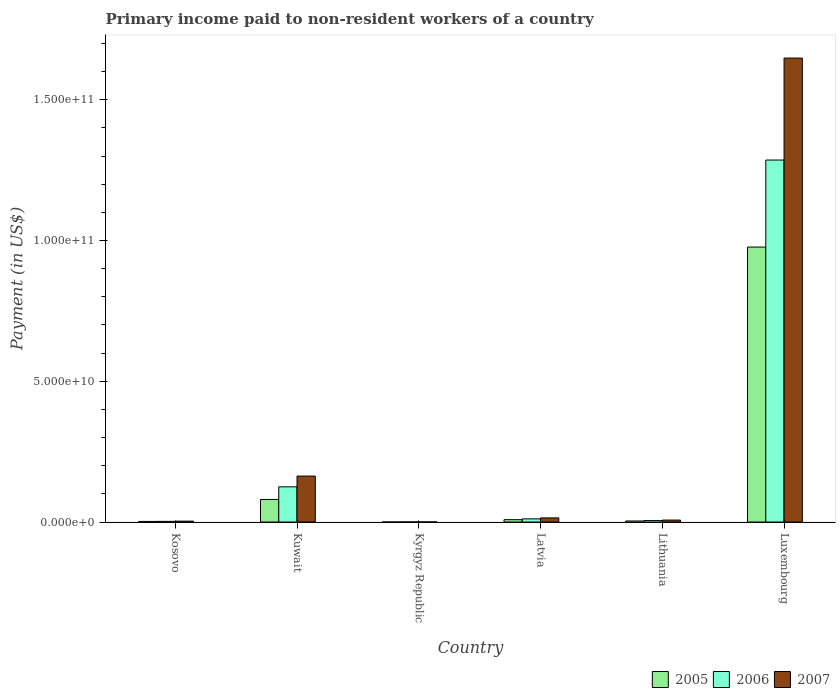How many different coloured bars are there?
Make the answer very short. 3. How many groups of bars are there?
Provide a succinct answer. 6. What is the label of the 6th group of bars from the left?
Provide a succinct answer. Luxembourg. In how many cases, is the number of bars for a given country not equal to the number of legend labels?
Your answer should be compact. 0. What is the amount paid to workers in 2007 in Latvia?
Give a very brief answer. 1.47e+09. Across all countries, what is the maximum amount paid to workers in 2006?
Your response must be concise. 1.29e+11. Across all countries, what is the minimum amount paid to workers in 2007?
Offer a very short reply. 4.26e+07. In which country was the amount paid to workers in 2007 maximum?
Keep it short and to the point. Luxembourg. In which country was the amount paid to workers in 2006 minimum?
Provide a succinct answer. Kyrgyz Republic. What is the total amount paid to workers in 2007 in the graph?
Your answer should be compact. 1.84e+11. What is the difference between the amount paid to workers in 2006 in Kyrgyz Republic and that in Luxembourg?
Offer a terse response. -1.29e+11. What is the difference between the amount paid to workers in 2006 in Luxembourg and the amount paid to workers in 2005 in Kosovo?
Your answer should be very brief. 1.28e+11. What is the average amount paid to workers in 2005 per country?
Your answer should be compact. 1.79e+1. What is the difference between the amount paid to workers of/in 2007 and amount paid to workers of/in 2006 in Latvia?
Ensure brevity in your answer.  3.44e+08. In how many countries, is the amount paid to workers in 2007 greater than 20000000000 US$?
Keep it short and to the point. 1. What is the ratio of the amount paid to workers in 2006 in Lithuania to that in Luxembourg?
Make the answer very short. 0. Is the difference between the amount paid to workers in 2007 in Lithuania and Luxembourg greater than the difference between the amount paid to workers in 2006 in Lithuania and Luxembourg?
Ensure brevity in your answer.  No. What is the difference between the highest and the second highest amount paid to workers in 2006?
Your answer should be compact. 1.27e+11. What is the difference between the highest and the lowest amount paid to workers in 2006?
Make the answer very short. 1.29e+11. What does the 3rd bar from the right in Kyrgyz Republic represents?
Provide a short and direct response. 2005. Is it the case that in every country, the sum of the amount paid to workers in 2006 and amount paid to workers in 2005 is greater than the amount paid to workers in 2007?
Make the answer very short. Yes. How many bars are there?
Offer a very short reply. 18. Are all the bars in the graph horizontal?
Ensure brevity in your answer.  No. How many countries are there in the graph?
Give a very brief answer. 6. Where does the legend appear in the graph?
Give a very brief answer. Bottom right. How many legend labels are there?
Your answer should be very brief. 3. How are the legend labels stacked?
Keep it short and to the point. Horizontal. What is the title of the graph?
Your answer should be very brief. Primary income paid to non-resident workers of a country. Does "1965" appear as one of the legend labels in the graph?
Give a very brief answer. No. What is the label or title of the Y-axis?
Offer a terse response. Payment (in US$). What is the Payment (in US$) in 2005 in Kosovo?
Your answer should be compact. 2.12e+08. What is the Payment (in US$) in 2006 in Kosovo?
Provide a short and direct response. 2.36e+08. What is the Payment (in US$) of 2007 in Kosovo?
Your answer should be compact. 3.23e+08. What is the Payment (in US$) in 2005 in Kuwait?
Offer a terse response. 8.02e+09. What is the Payment (in US$) in 2006 in Kuwait?
Give a very brief answer. 1.25e+1. What is the Payment (in US$) of 2007 in Kuwait?
Provide a succinct answer. 1.63e+1. What is the Payment (in US$) in 2005 in Kyrgyz Republic?
Offer a very short reply. 1.65e+07. What is the Payment (in US$) of 2006 in Kyrgyz Republic?
Provide a succinct answer. 4.16e+07. What is the Payment (in US$) of 2007 in Kyrgyz Republic?
Give a very brief answer. 4.26e+07. What is the Payment (in US$) in 2005 in Latvia?
Offer a terse response. 8.40e+08. What is the Payment (in US$) of 2006 in Latvia?
Your answer should be very brief. 1.13e+09. What is the Payment (in US$) of 2007 in Latvia?
Your answer should be very brief. 1.47e+09. What is the Payment (in US$) of 2005 in Lithuania?
Offer a terse response. 3.75e+08. What is the Payment (in US$) of 2006 in Lithuania?
Provide a short and direct response. 5.17e+08. What is the Payment (in US$) in 2007 in Lithuania?
Your answer should be compact. 6.99e+08. What is the Payment (in US$) of 2005 in Luxembourg?
Keep it short and to the point. 9.77e+1. What is the Payment (in US$) in 2006 in Luxembourg?
Offer a very short reply. 1.29e+11. What is the Payment (in US$) in 2007 in Luxembourg?
Keep it short and to the point. 1.65e+11. Across all countries, what is the maximum Payment (in US$) in 2005?
Your answer should be very brief. 9.77e+1. Across all countries, what is the maximum Payment (in US$) of 2006?
Offer a terse response. 1.29e+11. Across all countries, what is the maximum Payment (in US$) of 2007?
Provide a short and direct response. 1.65e+11. Across all countries, what is the minimum Payment (in US$) in 2005?
Give a very brief answer. 1.65e+07. Across all countries, what is the minimum Payment (in US$) in 2006?
Your answer should be compact. 4.16e+07. Across all countries, what is the minimum Payment (in US$) in 2007?
Keep it short and to the point. 4.26e+07. What is the total Payment (in US$) in 2005 in the graph?
Make the answer very short. 1.07e+11. What is the total Payment (in US$) in 2006 in the graph?
Offer a very short reply. 1.43e+11. What is the total Payment (in US$) in 2007 in the graph?
Offer a very short reply. 1.84e+11. What is the difference between the Payment (in US$) of 2005 in Kosovo and that in Kuwait?
Keep it short and to the point. -7.81e+09. What is the difference between the Payment (in US$) of 2006 in Kosovo and that in Kuwait?
Offer a terse response. -1.23e+1. What is the difference between the Payment (in US$) in 2007 in Kosovo and that in Kuwait?
Your answer should be very brief. -1.60e+1. What is the difference between the Payment (in US$) in 2005 in Kosovo and that in Kyrgyz Republic?
Make the answer very short. 1.95e+08. What is the difference between the Payment (in US$) of 2006 in Kosovo and that in Kyrgyz Republic?
Keep it short and to the point. 1.94e+08. What is the difference between the Payment (in US$) of 2007 in Kosovo and that in Kyrgyz Republic?
Offer a very short reply. 2.80e+08. What is the difference between the Payment (in US$) of 2005 in Kosovo and that in Latvia?
Provide a short and direct response. -6.28e+08. What is the difference between the Payment (in US$) in 2006 in Kosovo and that in Latvia?
Offer a very short reply. -8.91e+08. What is the difference between the Payment (in US$) in 2007 in Kosovo and that in Latvia?
Give a very brief answer. -1.15e+09. What is the difference between the Payment (in US$) in 2005 in Kosovo and that in Lithuania?
Your answer should be very brief. -1.63e+08. What is the difference between the Payment (in US$) of 2006 in Kosovo and that in Lithuania?
Provide a short and direct response. -2.82e+08. What is the difference between the Payment (in US$) in 2007 in Kosovo and that in Lithuania?
Make the answer very short. -3.76e+08. What is the difference between the Payment (in US$) in 2005 in Kosovo and that in Luxembourg?
Give a very brief answer. -9.74e+1. What is the difference between the Payment (in US$) of 2006 in Kosovo and that in Luxembourg?
Keep it short and to the point. -1.28e+11. What is the difference between the Payment (in US$) of 2007 in Kosovo and that in Luxembourg?
Make the answer very short. -1.64e+11. What is the difference between the Payment (in US$) in 2005 in Kuwait and that in Kyrgyz Republic?
Keep it short and to the point. 8.01e+09. What is the difference between the Payment (in US$) in 2006 in Kuwait and that in Kyrgyz Republic?
Your answer should be very brief. 1.25e+1. What is the difference between the Payment (in US$) in 2007 in Kuwait and that in Kyrgyz Republic?
Your answer should be compact. 1.63e+1. What is the difference between the Payment (in US$) in 2005 in Kuwait and that in Latvia?
Ensure brevity in your answer.  7.18e+09. What is the difference between the Payment (in US$) in 2006 in Kuwait and that in Latvia?
Keep it short and to the point. 1.14e+1. What is the difference between the Payment (in US$) in 2007 in Kuwait and that in Latvia?
Ensure brevity in your answer.  1.49e+1. What is the difference between the Payment (in US$) of 2005 in Kuwait and that in Lithuania?
Make the answer very short. 7.65e+09. What is the difference between the Payment (in US$) in 2006 in Kuwait and that in Lithuania?
Make the answer very short. 1.20e+1. What is the difference between the Payment (in US$) of 2007 in Kuwait and that in Lithuania?
Keep it short and to the point. 1.56e+1. What is the difference between the Payment (in US$) in 2005 in Kuwait and that in Luxembourg?
Provide a short and direct response. -8.96e+1. What is the difference between the Payment (in US$) in 2006 in Kuwait and that in Luxembourg?
Offer a very short reply. -1.16e+11. What is the difference between the Payment (in US$) in 2007 in Kuwait and that in Luxembourg?
Make the answer very short. -1.48e+11. What is the difference between the Payment (in US$) of 2005 in Kyrgyz Republic and that in Latvia?
Provide a short and direct response. -8.23e+08. What is the difference between the Payment (in US$) of 2006 in Kyrgyz Republic and that in Latvia?
Offer a terse response. -1.09e+09. What is the difference between the Payment (in US$) of 2007 in Kyrgyz Republic and that in Latvia?
Make the answer very short. -1.43e+09. What is the difference between the Payment (in US$) in 2005 in Kyrgyz Republic and that in Lithuania?
Make the answer very short. -3.58e+08. What is the difference between the Payment (in US$) in 2006 in Kyrgyz Republic and that in Lithuania?
Provide a succinct answer. -4.76e+08. What is the difference between the Payment (in US$) of 2007 in Kyrgyz Republic and that in Lithuania?
Offer a terse response. -6.56e+08. What is the difference between the Payment (in US$) of 2005 in Kyrgyz Republic and that in Luxembourg?
Ensure brevity in your answer.  -9.76e+1. What is the difference between the Payment (in US$) of 2006 in Kyrgyz Republic and that in Luxembourg?
Provide a short and direct response. -1.29e+11. What is the difference between the Payment (in US$) in 2007 in Kyrgyz Republic and that in Luxembourg?
Provide a succinct answer. -1.65e+11. What is the difference between the Payment (in US$) of 2005 in Latvia and that in Lithuania?
Offer a very short reply. 4.65e+08. What is the difference between the Payment (in US$) in 2006 in Latvia and that in Lithuania?
Keep it short and to the point. 6.10e+08. What is the difference between the Payment (in US$) in 2007 in Latvia and that in Lithuania?
Offer a very short reply. 7.72e+08. What is the difference between the Payment (in US$) in 2005 in Latvia and that in Luxembourg?
Make the answer very short. -9.68e+1. What is the difference between the Payment (in US$) of 2006 in Latvia and that in Luxembourg?
Your answer should be very brief. -1.27e+11. What is the difference between the Payment (in US$) of 2007 in Latvia and that in Luxembourg?
Your answer should be compact. -1.63e+11. What is the difference between the Payment (in US$) in 2005 in Lithuania and that in Luxembourg?
Your answer should be very brief. -9.73e+1. What is the difference between the Payment (in US$) of 2006 in Lithuania and that in Luxembourg?
Keep it short and to the point. -1.28e+11. What is the difference between the Payment (in US$) of 2007 in Lithuania and that in Luxembourg?
Give a very brief answer. -1.64e+11. What is the difference between the Payment (in US$) in 2005 in Kosovo and the Payment (in US$) in 2006 in Kuwait?
Your response must be concise. -1.23e+1. What is the difference between the Payment (in US$) of 2005 in Kosovo and the Payment (in US$) of 2007 in Kuwait?
Your answer should be very brief. -1.61e+1. What is the difference between the Payment (in US$) of 2006 in Kosovo and the Payment (in US$) of 2007 in Kuwait?
Provide a short and direct response. -1.61e+1. What is the difference between the Payment (in US$) in 2005 in Kosovo and the Payment (in US$) in 2006 in Kyrgyz Republic?
Offer a very short reply. 1.70e+08. What is the difference between the Payment (in US$) of 2005 in Kosovo and the Payment (in US$) of 2007 in Kyrgyz Republic?
Offer a very short reply. 1.69e+08. What is the difference between the Payment (in US$) in 2006 in Kosovo and the Payment (in US$) in 2007 in Kyrgyz Republic?
Provide a short and direct response. 1.93e+08. What is the difference between the Payment (in US$) in 2005 in Kosovo and the Payment (in US$) in 2006 in Latvia?
Offer a terse response. -9.15e+08. What is the difference between the Payment (in US$) in 2005 in Kosovo and the Payment (in US$) in 2007 in Latvia?
Your response must be concise. -1.26e+09. What is the difference between the Payment (in US$) of 2006 in Kosovo and the Payment (in US$) of 2007 in Latvia?
Your answer should be compact. -1.24e+09. What is the difference between the Payment (in US$) in 2005 in Kosovo and the Payment (in US$) in 2006 in Lithuania?
Provide a succinct answer. -3.05e+08. What is the difference between the Payment (in US$) of 2005 in Kosovo and the Payment (in US$) of 2007 in Lithuania?
Ensure brevity in your answer.  -4.87e+08. What is the difference between the Payment (in US$) in 2006 in Kosovo and the Payment (in US$) in 2007 in Lithuania?
Provide a short and direct response. -4.63e+08. What is the difference between the Payment (in US$) of 2005 in Kosovo and the Payment (in US$) of 2006 in Luxembourg?
Offer a very short reply. -1.28e+11. What is the difference between the Payment (in US$) of 2005 in Kosovo and the Payment (in US$) of 2007 in Luxembourg?
Offer a terse response. -1.65e+11. What is the difference between the Payment (in US$) in 2006 in Kosovo and the Payment (in US$) in 2007 in Luxembourg?
Offer a very short reply. -1.65e+11. What is the difference between the Payment (in US$) in 2005 in Kuwait and the Payment (in US$) in 2006 in Kyrgyz Republic?
Keep it short and to the point. 7.98e+09. What is the difference between the Payment (in US$) in 2005 in Kuwait and the Payment (in US$) in 2007 in Kyrgyz Republic?
Your answer should be compact. 7.98e+09. What is the difference between the Payment (in US$) in 2006 in Kuwait and the Payment (in US$) in 2007 in Kyrgyz Republic?
Ensure brevity in your answer.  1.25e+1. What is the difference between the Payment (in US$) in 2005 in Kuwait and the Payment (in US$) in 2006 in Latvia?
Your answer should be very brief. 6.90e+09. What is the difference between the Payment (in US$) of 2005 in Kuwait and the Payment (in US$) of 2007 in Latvia?
Your response must be concise. 6.55e+09. What is the difference between the Payment (in US$) in 2006 in Kuwait and the Payment (in US$) in 2007 in Latvia?
Your answer should be compact. 1.10e+1. What is the difference between the Payment (in US$) of 2005 in Kuwait and the Payment (in US$) of 2006 in Lithuania?
Provide a short and direct response. 7.51e+09. What is the difference between the Payment (in US$) in 2005 in Kuwait and the Payment (in US$) in 2007 in Lithuania?
Keep it short and to the point. 7.32e+09. What is the difference between the Payment (in US$) in 2006 in Kuwait and the Payment (in US$) in 2007 in Lithuania?
Your answer should be compact. 1.18e+1. What is the difference between the Payment (in US$) of 2005 in Kuwait and the Payment (in US$) of 2006 in Luxembourg?
Offer a terse response. -1.21e+11. What is the difference between the Payment (in US$) in 2005 in Kuwait and the Payment (in US$) in 2007 in Luxembourg?
Your answer should be very brief. -1.57e+11. What is the difference between the Payment (in US$) of 2006 in Kuwait and the Payment (in US$) of 2007 in Luxembourg?
Your answer should be very brief. -1.52e+11. What is the difference between the Payment (in US$) in 2005 in Kyrgyz Republic and the Payment (in US$) in 2006 in Latvia?
Make the answer very short. -1.11e+09. What is the difference between the Payment (in US$) in 2005 in Kyrgyz Republic and the Payment (in US$) in 2007 in Latvia?
Your response must be concise. -1.45e+09. What is the difference between the Payment (in US$) of 2006 in Kyrgyz Republic and the Payment (in US$) of 2007 in Latvia?
Ensure brevity in your answer.  -1.43e+09. What is the difference between the Payment (in US$) of 2005 in Kyrgyz Republic and the Payment (in US$) of 2006 in Lithuania?
Provide a short and direct response. -5.01e+08. What is the difference between the Payment (in US$) in 2005 in Kyrgyz Republic and the Payment (in US$) in 2007 in Lithuania?
Offer a terse response. -6.82e+08. What is the difference between the Payment (in US$) in 2006 in Kyrgyz Republic and the Payment (in US$) in 2007 in Lithuania?
Provide a short and direct response. -6.57e+08. What is the difference between the Payment (in US$) in 2005 in Kyrgyz Republic and the Payment (in US$) in 2006 in Luxembourg?
Provide a succinct answer. -1.29e+11. What is the difference between the Payment (in US$) of 2005 in Kyrgyz Republic and the Payment (in US$) of 2007 in Luxembourg?
Provide a short and direct response. -1.65e+11. What is the difference between the Payment (in US$) of 2006 in Kyrgyz Republic and the Payment (in US$) of 2007 in Luxembourg?
Your answer should be compact. -1.65e+11. What is the difference between the Payment (in US$) in 2005 in Latvia and the Payment (in US$) in 2006 in Lithuania?
Your response must be concise. 3.22e+08. What is the difference between the Payment (in US$) in 2005 in Latvia and the Payment (in US$) in 2007 in Lithuania?
Your answer should be very brief. 1.41e+08. What is the difference between the Payment (in US$) of 2006 in Latvia and the Payment (in US$) of 2007 in Lithuania?
Your answer should be compact. 4.28e+08. What is the difference between the Payment (in US$) of 2005 in Latvia and the Payment (in US$) of 2006 in Luxembourg?
Provide a short and direct response. -1.28e+11. What is the difference between the Payment (in US$) of 2005 in Latvia and the Payment (in US$) of 2007 in Luxembourg?
Your answer should be very brief. -1.64e+11. What is the difference between the Payment (in US$) in 2006 in Latvia and the Payment (in US$) in 2007 in Luxembourg?
Make the answer very short. -1.64e+11. What is the difference between the Payment (in US$) in 2005 in Lithuania and the Payment (in US$) in 2006 in Luxembourg?
Provide a short and direct response. -1.28e+11. What is the difference between the Payment (in US$) of 2005 in Lithuania and the Payment (in US$) of 2007 in Luxembourg?
Provide a succinct answer. -1.64e+11. What is the difference between the Payment (in US$) of 2006 in Lithuania and the Payment (in US$) of 2007 in Luxembourg?
Ensure brevity in your answer.  -1.64e+11. What is the average Payment (in US$) in 2005 per country?
Make the answer very short. 1.79e+1. What is the average Payment (in US$) of 2006 per country?
Ensure brevity in your answer.  2.38e+1. What is the average Payment (in US$) in 2007 per country?
Offer a very short reply. 3.06e+1. What is the difference between the Payment (in US$) of 2005 and Payment (in US$) of 2006 in Kosovo?
Provide a short and direct response. -2.36e+07. What is the difference between the Payment (in US$) of 2005 and Payment (in US$) of 2007 in Kosovo?
Make the answer very short. -1.11e+08. What is the difference between the Payment (in US$) in 2006 and Payment (in US$) in 2007 in Kosovo?
Offer a very short reply. -8.69e+07. What is the difference between the Payment (in US$) in 2005 and Payment (in US$) in 2006 in Kuwait?
Offer a very short reply. -4.48e+09. What is the difference between the Payment (in US$) in 2005 and Payment (in US$) in 2007 in Kuwait?
Keep it short and to the point. -8.30e+09. What is the difference between the Payment (in US$) of 2006 and Payment (in US$) of 2007 in Kuwait?
Offer a very short reply. -3.83e+09. What is the difference between the Payment (in US$) in 2005 and Payment (in US$) in 2006 in Kyrgyz Republic?
Provide a succinct answer. -2.51e+07. What is the difference between the Payment (in US$) of 2005 and Payment (in US$) of 2007 in Kyrgyz Republic?
Offer a terse response. -2.61e+07. What is the difference between the Payment (in US$) in 2006 and Payment (in US$) in 2007 in Kyrgyz Republic?
Your answer should be very brief. -1.00e+06. What is the difference between the Payment (in US$) in 2005 and Payment (in US$) in 2006 in Latvia?
Ensure brevity in your answer.  -2.87e+08. What is the difference between the Payment (in US$) of 2005 and Payment (in US$) of 2007 in Latvia?
Keep it short and to the point. -6.31e+08. What is the difference between the Payment (in US$) of 2006 and Payment (in US$) of 2007 in Latvia?
Make the answer very short. -3.44e+08. What is the difference between the Payment (in US$) in 2005 and Payment (in US$) in 2006 in Lithuania?
Make the answer very short. -1.42e+08. What is the difference between the Payment (in US$) of 2005 and Payment (in US$) of 2007 in Lithuania?
Offer a terse response. -3.24e+08. What is the difference between the Payment (in US$) of 2006 and Payment (in US$) of 2007 in Lithuania?
Ensure brevity in your answer.  -1.82e+08. What is the difference between the Payment (in US$) in 2005 and Payment (in US$) in 2006 in Luxembourg?
Provide a succinct answer. -3.09e+1. What is the difference between the Payment (in US$) of 2005 and Payment (in US$) of 2007 in Luxembourg?
Keep it short and to the point. -6.71e+1. What is the difference between the Payment (in US$) in 2006 and Payment (in US$) in 2007 in Luxembourg?
Give a very brief answer. -3.62e+1. What is the ratio of the Payment (in US$) in 2005 in Kosovo to that in Kuwait?
Offer a very short reply. 0.03. What is the ratio of the Payment (in US$) of 2006 in Kosovo to that in Kuwait?
Make the answer very short. 0.02. What is the ratio of the Payment (in US$) in 2007 in Kosovo to that in Kuwait?
Offer a terse response. 0.02. What is the ratio of the Payment (in US$) in 2005 in Kosovo to that in Kyrgyz Republic?
Keep it short and to the point. 12.82. What is the ratio of the Payment (in US$) in 2006 in Kosovo to that in Kyrgyz Republic?
Your response must be concise. 5.66. What is the ratio of the Payment (in US$) of 2007 in Kosovo to that in Kyrgyz Republic?
Your answer should be very brief. 7.57. What is the ratio of the Payment (in US$) in 2005 in Kosovo to that in Latvia?
Give a very brief answer. 0.25. What is the ratio of the Payment (in US$) in 2006 in Kosovo to that in Latvia?
Your answer should be very brief. 0.21. What is the ratio of the Payment (in US$) in 2007 in Kosovo to that in Latvia?
Offer a very short reply. 0.22. What is the ratio of the Payment (in US$) of 2005 in Kosovo to that in Lithuania?
Make the answer very short. 0.57. What is the ratio of the Payment (in US$) in 2006 in Kosovo to that in Lithuania?
Your answer should be very brief. 0.46. What is the ratio of the Payment (in US$) in 2007 in Kosovo to that in Lithuania?
Make the answer very short. 0.46. What is the ratio of the Payment (in US$) in 2005 in Kosovo to that in Luxembourg?
Provide a short and direct response. 0. What is the ratio of the Payment (in US$) in 2006 in Kosovo to that in Luxembourg?
Keep it short and to the point. 0. What is the ratio of the Payment (in US$) in 2007 in Kosovo to that in Luxembourg?
Offer a terse response. 0. What is the ratio of the Payment (in US$) in 2005 in Kuwait to that in Kyrgyz Republic?
Keep it short and to the point. 485.22. What is the ratio of the Payment (in US$) of 2006 in Kuwait to that in Kyrgyz Republic?
Your response must be concise. 300.29. What is the ratio of the Payment (in US$) of 2007 in Kuwait to that in Kyrgyz Republic?
Offer a very short reply. 383.03. What is the ratio of the Payment (in US$) of 2005 in Kuwait to that in Latvia?
Give a very brief answer. 9.55. What is the ratio of the Payment (in US$) in 2006 in Kuwait to that in Latvia?
Your response must be concise. 11.09. What is the ratio of the Payment (in US$) of 2007 in Kuwait to that in Latvia?
Provide a short and direct response. 11.1. What is the ratio of the Payment (in US$) in 2005 in Kuwait to that in Lithuania?
Ensure brevity in your answer.  21.4. What is the ratio of the Payment (in US$) in 2006 in Kuwait to that in Lithuania?
Your answer should be very brief. 24.16. What is the ratio of the Payment (in US$) of 2007 in Kuwait to that in Lithuania?
Offer a very short reply. 23.36. What is the ratio of the Payment (in US$) of 2005 in Kuwait to that in Luxembourg?
Offer a very short reply. 0.08. What is the ratio of the Payment (in US$) of 2006 in Kuwait to that in Luxembourg?
Give a very brief answer. 0.1. What is the ratio of the Payment (in US$) of 2007 in Kuwait to that in Luxembourg?
Keep it short and to the point. 0.1. What is the ratio of the Payment (in US$) of 2005 in Kyrgyz Republic to that in Latvia?
Offer a very short reply. 0.02. What is the ratio of the Payment (in US$) of 2006 in Kyrgyz Republic to that in Latvia?
Make the answer very short. 0.04. What is the ratio of the Payment (in US$) of 2007 in Kyrgyz Republic to that in Latvia?
Offer a terse response. 0.03. What is the ratio of the Payment (in US$) of 2005 in Kyrgyz Republic to that in Lithuania?
Your answer should be very brief. 0.04. What is the ratio of the Payment (in US$) in 2006 in Kyrgyz Republic to that in Lithuania?
Keep it short and to the point. 0.08. What is the ratio of the Payment (in US$) of 2007 in Kyrgyz Republic to that in Lithuania?
Your response must be concise. 0.06. What is the ratio of the Payment (in US$) in 2005 in Kyrgyz Republic to that in Luxembourg?
Offer a very short reply. 0. What is the ratio of the Payment (in US$) of 2006 in Kyrgyz Republic to that in Luxembourg?
Offer a very short reply. 0. What is the ratio of the Payment (in US$) in 2007 in Kyrgyz Republic to that in Luxembourg?
Keep it short and to the point. 0. What is the ratio of the Payment (in US$) in 2005 in Latvia to that in Lithuania?
Ensure brevity in your answer.  2.24. What is the ratio of the Payment (in US$) of 2006 in Latvia to that in Lithuania?
Your answer should be compact. 2.18. What is the ratio of the Payment (in US$) of 2007 in Latvia to that in Lithuania?
Ensure brevity in your answer.  2.1. What is the ratio of the Payment (in US$) of 2005 in Latvia to that in Luxembourg?
Ensure brevity in your answer.  0.01. What is the ratio of the Payment (in US$) of 2006 in Latvia to that in Luxembourg?
Your answer should be very brief. 0.01. What is the ratio of the Payment (in US$) in 2007 in Latvia to that in Luxembourg?
Your answer should be very brief. 0.01. What is the ratio of the Payment (in US$) in 2005 in Lithuania to that in Luxembourg?
Your answer should be compact. 0. What is the ratio of the Payment (in US$) in 2006 in Lithuania to that in Luxembourg?
Give a very brief answer. 0. What is the ratio of the Payment (in US$) in 2007 in Lithuania to that in Luxembourg?
Give a very brief answer. 0. What is the difference between the highest and the second highest Payment (in US$) of 2005?
Provide a succinct answer. 8.96e+1. What is the difference between the highest and the second highest Payment (in US$) of 2006?
Provide a succinct answer. 1.16e+11. What is the difference between the highest and the second highest Payment (in US$) of 2007?
Provide a short and direct response. 1.48e+11. What is the difference between the highest and the lowest Payment (in US$) in 2005?
Give a very brief answer. 9.76e+1. What is the difference between the highest and the lowest Payment (in US$) of 2006?
Your answer should be compact. 1.29e+11. What is the difference between the highest and the lowest Payment (in US$) of 2007?
Give a very brief answer. 1.65e+11. 